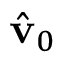Convert formula to latex. <formula><loc_0><loc_0><loc_500><loc_500>\hat { v } _ { 0 }</formula> 